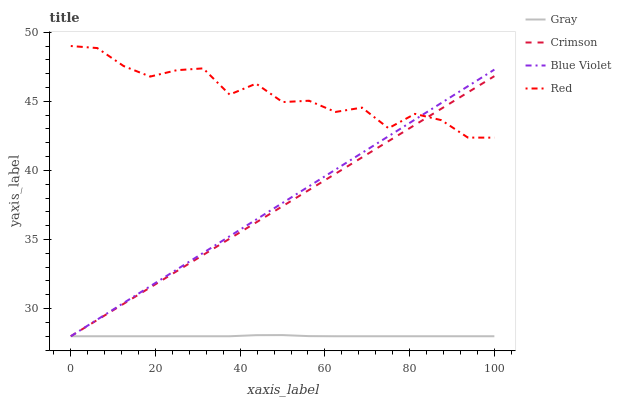Does Gray have the minimum area under the curve?
Answer yes or no. Yes. Does Red have the maximum area under the curve?
Answer yes or no. Yes. Does Red have the minimum area under the curve?
Answer yes or no. No. Does Gray have the maximum area under the curve?
Answer yes or no. No. Is Crimson the smoothest?
Answer yes or no. Yes. Is Red the roughest?
Answer yes or no. Yes. Is Gray the smoothest?
Answer yes or no. No. Is Gray the roughest?
Answer yes or no. No. Does Crimson have the lowest value?
Answer yes or no. Yes. Does Red have the lowest value?
Answer yes or no. No. Does Red have the highest value?
Answer yes or no. Yes. Does Gray have the highest value?
Answer yes or no. No. Is Gray less than Red?
Answer yes or no. Yes. Is Red greater than Gray?
Answer yes or no. Yes. Does Blue Violet intersect Red?
Answer yes or no. Yes. Is Blue Violet less than Red?
Answer yes or no. No. Is Blue Violet greater than Red?
Answer yes or no. No. Does Gray intersect Red?
Answer yes or no. No. 